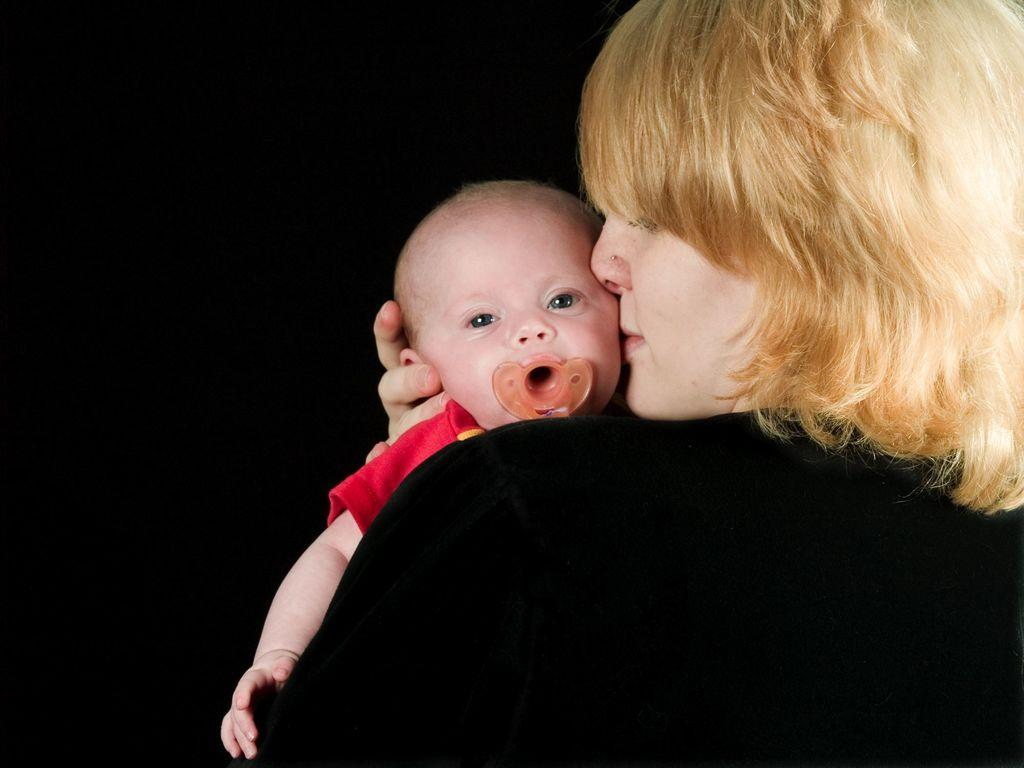Who is the main subject in the image? There is a woman in the image. What is the woman wearing? The woman is wearing a black dress. What is the woman doing in the image? The woman is holding a baby. What can be seen in the background of the image? The background of the image has a dark view. What color is the paint on the ocean in the image? There is no ocean or paint present in the image. Is the sink visible in the image? There is no sink present in the image. 